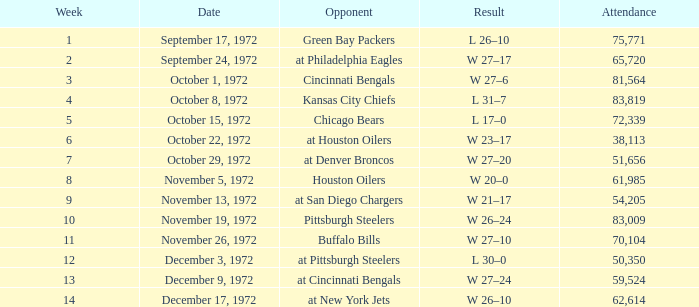What is the sum of week number(s) had an attendance of 61,985? 1.0. 